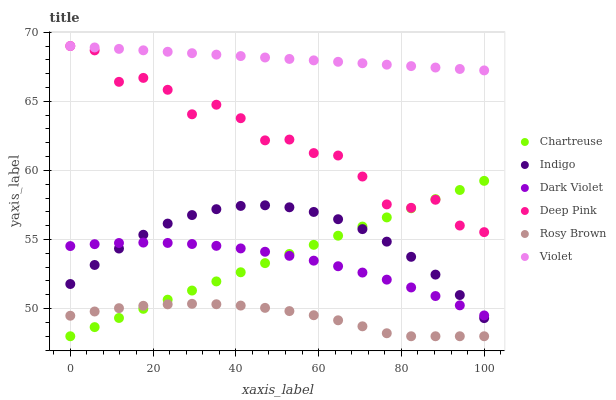Does Rosy Brown have the minimum area under the curve?
Answer yes or no. Yes. Does Violet have the maximum area under the curve?
Answer yes or no. Yes. Does Indigo have the minimum area under the curve?
Answer yes or no. No. Does Indigo have the maximum area under the curve?
Answer yes or no. No. Is Chartreuse the smoothest?
Answer yes or no. Yes. Is Deep Pink the roughest?
Answer yes or no. Yes. Is Indigo the smoothest?
Answer yes or no. No. Is Indigo the roughest?
Answer yes or no. No. Does Rosy Brown have the lowest value?
Answer yes or no. Yes. Does Indigo have the lowest value?
Answer yes or no. No. Does Violet have the highest value?
Answer yes or no. Yes. Does Indigo have the highest value?
Answer yes or no. No. Is Rosy Brown less than Dark Violet?
Answer yes or no. Yes. Is Dark Violet greater than Rosy Brown?
Answer yes or no. Yes. Does Indigo intersect Dark Violet?
Answer yes or no. Yes. Is Indigo less than Dark Violet?
Answer yes or no. No. Is Indigo greater than Dark Violet?
Answer yes or no. No. Does Rosy Brown intersect Dark Violet?
Answer yes or no. No. 